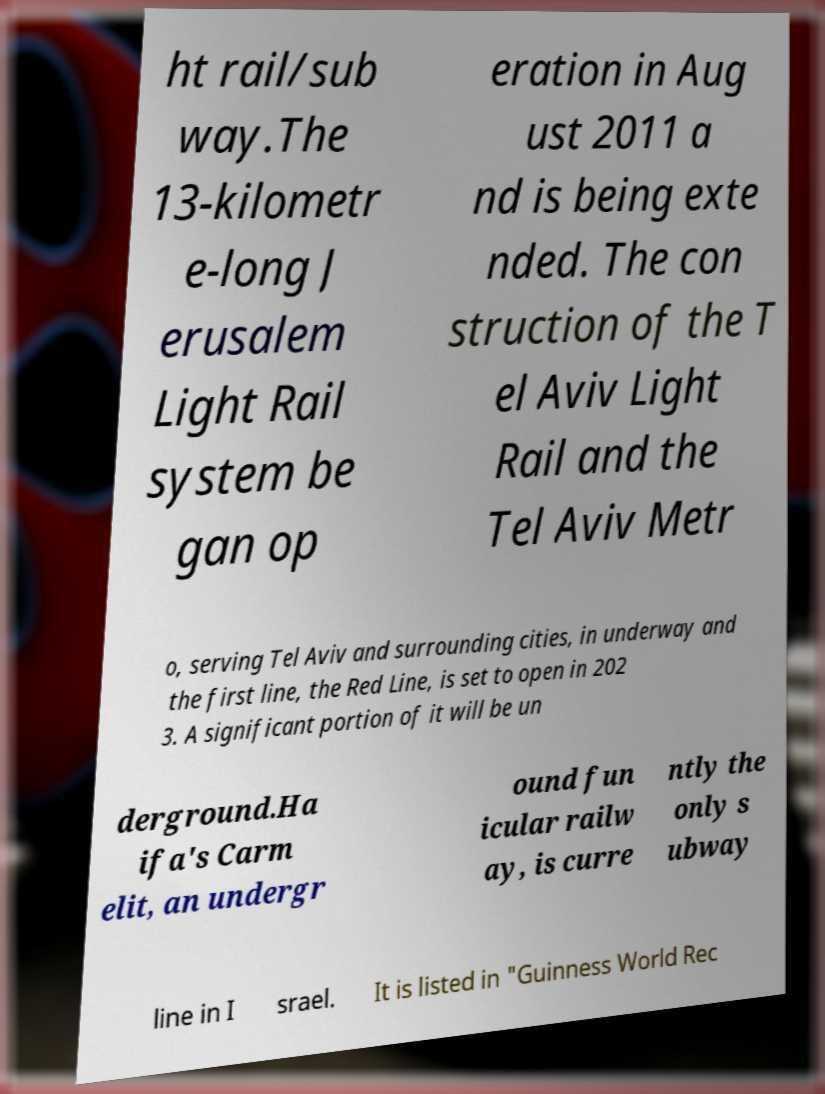Can you accurately transcribe the text from the provided image for me? ht rail/sub way.The 13-kilometr e-long J erusalem Light Rail system be gan op eration in Aug ust 2011 a nd is being exte nded. The con struction of the T el Aviv Light Rail and the Tel Aviv Metr o, serving Tel Aviv and surrounding cities, in underway and the first line, the Red Line, is set to open in 202 3. A significant portion of it will be un derground.Ha ifa's Carm elit, an undergr ound fun icular railw ay, is curre ntly the only s ubway line in I srael. It is listed in "Guinness World Rec 